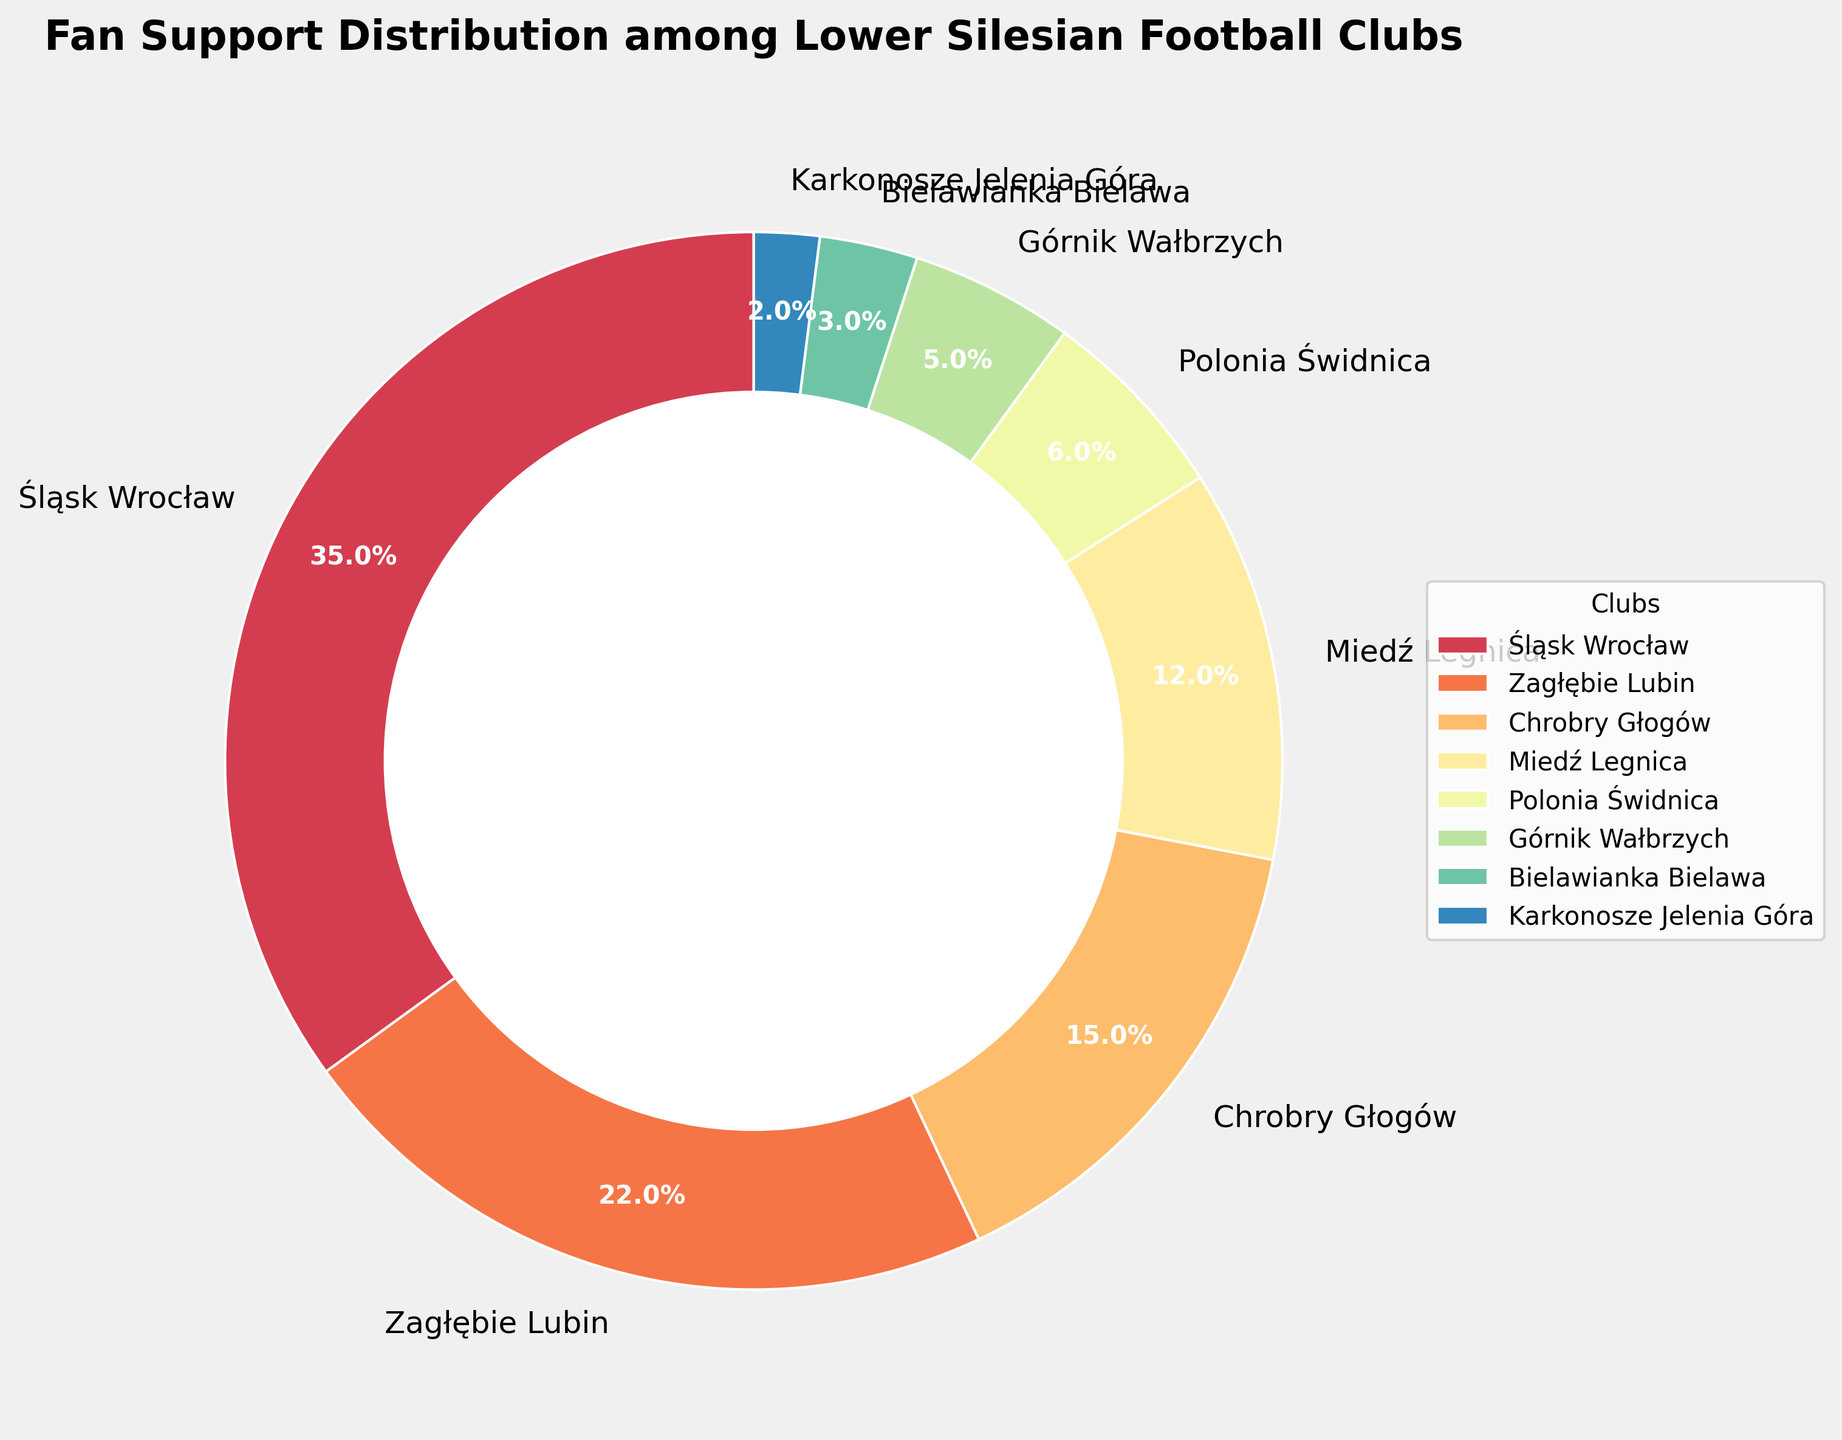Which club has the highest fan support percentage? By examining the pie chart, we see that Śląsk Wrocław has the largest segment. The chart shows that Śląsk Wrocław has 35% fan support.
Answer: Śląsk Wrocław What is the combined fan support percentage for Chrobry Głogów and Miedź Legnica? The pie chart shows Chrobry Głogów with 15% and Miedź Legnica with 12%. Adding these percentages gives 15% + 12% = 27%.
Answer: 27% How much more fan support does Zagłębie Lubin have compared to Chrobry Głogów? Zagłębie Lubin has 22% support, and Chrobry Głogów has 15%. The difference is 22% - 15% = 7%.
Answer: 7% Which club has the lowest fan support percentage and what is it? Reviewing the pie chart, Karkonosze Jelenia Góra appears with the smallest segment, highlighted at 2%.
Answer: Karkonosze Jelenia Góra, 2% What is the average fan support percentage for the clubs with less than 10% support? The clubs are Polonia Świdnica (6%), Górnik Wałbrzych (5%), Bielawianka Bielawa (3%), and Karkonosze Jelenia Góra (2%). Their average support is calculated as (6% + 5% + 3% + 2%) / 4 = 16% / 4 = 4%.
Answer: 4% Does Śląsk Wrocław have more than twice the fan support of Miedź Legnica? Śląsk Wrocław has 35% fan support, and Miedź Legnica has 12%. Twice the support of Miedź Legnica is 2 * 12% = 24%. Since 35% is greater than 24%, Śląsk Wrocław has more than twice the fan support.
Answer: Yes Which club has a fan support percentage closest to 5%? The club with fan support closest to 5% is Górnik Wałbrzych, which matches 5% exactly.
Answer: Górnik Wałbrzych 